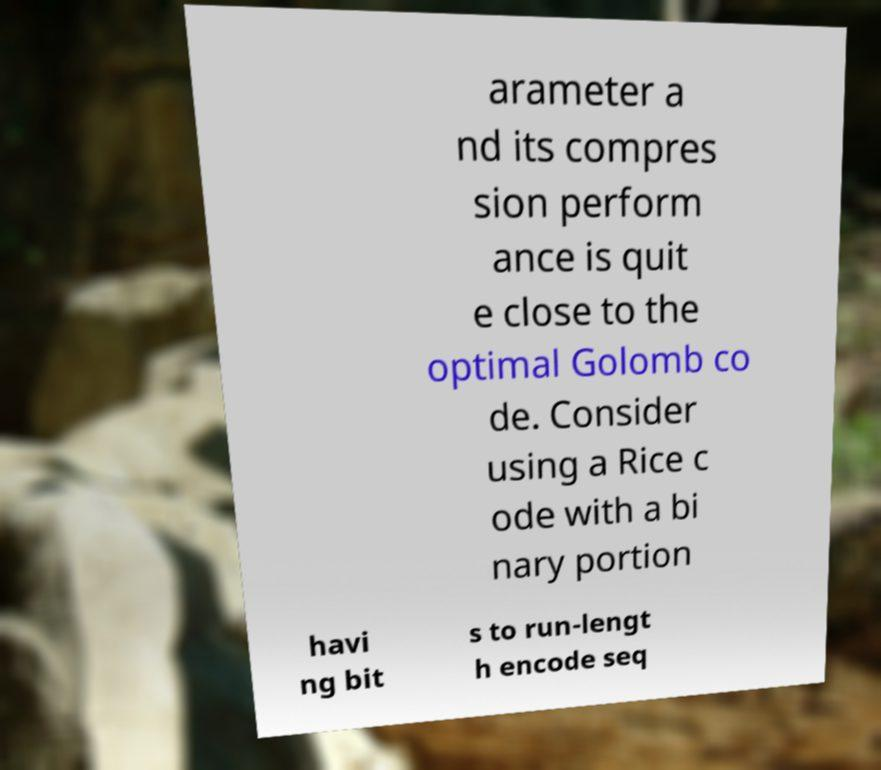There's text embedded in this image that I need extracted. Can you transcribe it verbatim? arameter a nd its compres sion perform ance is quit e close to the optimal Golomb co de. Consider using a Rice c ode with a bi nary portion havi ng bit s to run-lengt h encode seq 